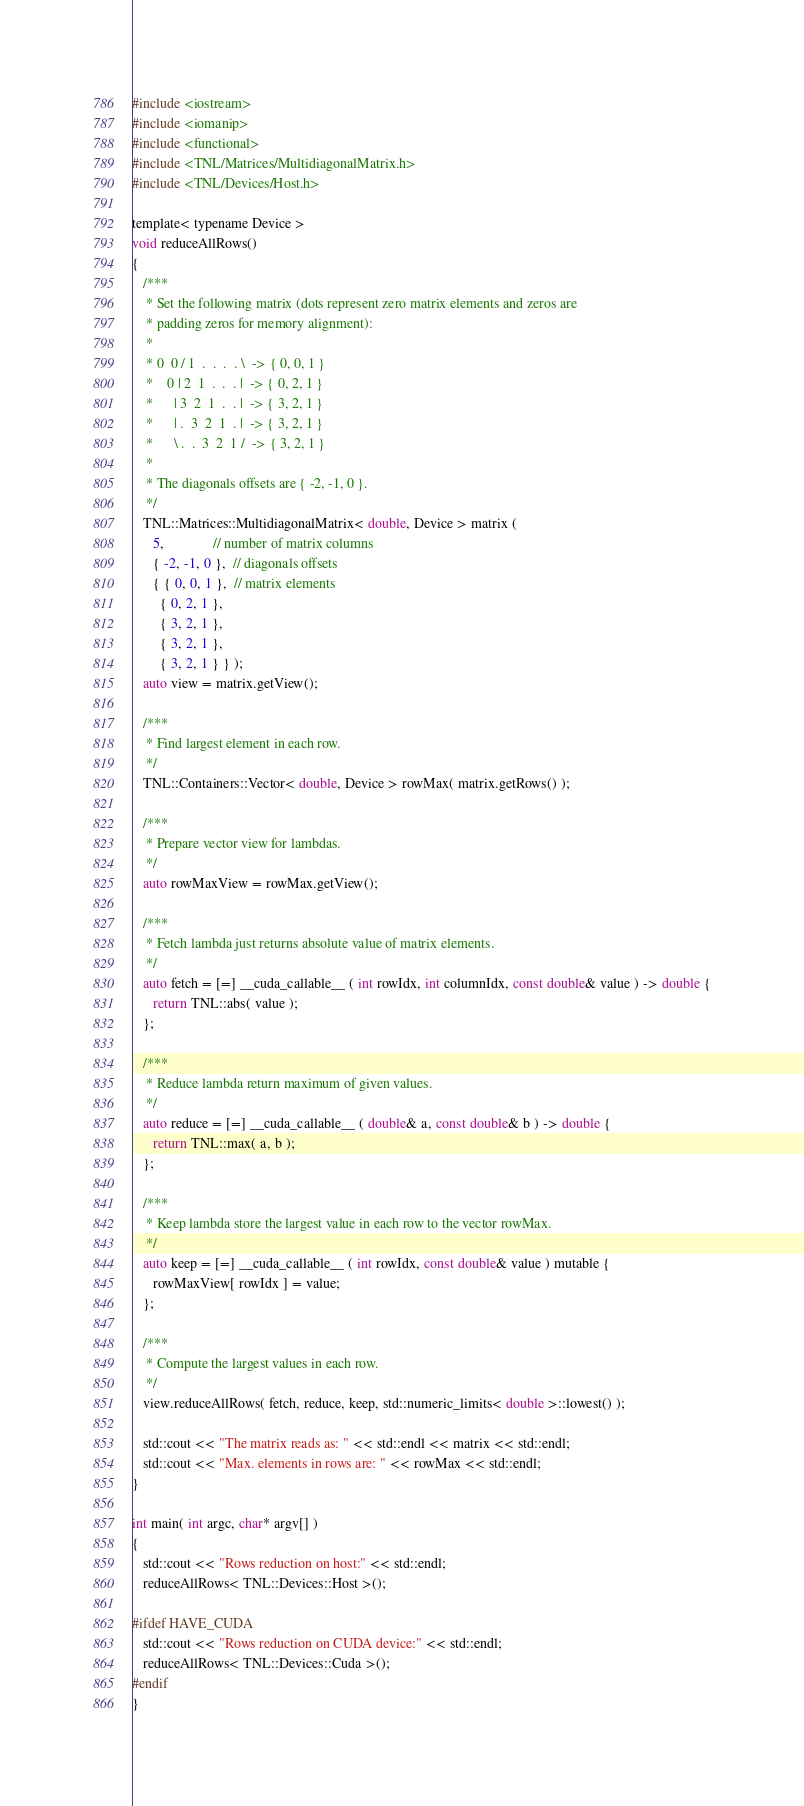Convert code to text. <code><loc_0><loc_0><loc_500><loc_500><_Cuda_>#include <iostream>
#include <iomanip>
#include <functional>
#include <TNL/Matrices/MultidiagonalMatrix.h>
#include <TNL/Devices/Host.h>

template< typename Device >
void reduceAllRows()
{
   /***
    * Set the following matrix (dots represent zero matrix elements and zeros are
    * padding zeros for memory alignment):
    *
    * 0  0 / 1  .  .  .  . \  -> { 0, 0, 1 }
    *    0 | 2  1  .  .  . |  -> { 0, 2, 1 }
    *      | 3  2  1  .  . |  -> { 3, 2, 1 }
    *      | .  3  2  1  . |  -> { 3, 2, 1 }
    *      \ .  .  3  2  1 /  -> { 3, 2, 1 }
    *
    * The diagonals offsets are { -2, -1, 0 }.
    */
   TNL::Matrices::MultidiagonalMatrix< double, Device > matrix (
      5,              // number of matrix columns
      { -2, -1, 0 },  // diagonals offsets
      { { 0, 0, 1 },  // matrix elements
        { 0, 2, 1 },
        { 3, 2, 1 },
        { 3, 2, 1 },
        { 3, 2, 1 } } );
   auto view = matrix.getView();

   /***
    * Find largest element in each row.
    */
   TNL::Containers::Vector< double, Device > rowMax( matrix.getRows() );

   /***
    * Prepare vector view for lambdas.
    */
   auto rowMaxView = rowMax.getView();

   /***
    * Fetch lambda just returns absolute value of matrix elements.
    */
   auto fetch = [=] __cuda_callable__ ( int rowIdx, int columnIdx, const double& value ) -> double {
      return TNL::abs( value );
   };

   /***
    * Reduce lambda return maximum of given values.
    */
   auto reduce = [=] __cuda_callable__ ( double& a, const double& b ) -> double {
      return TNL::max( a, b );
   };

   /***
    * Keep lambda store the largest value in each row to the vector rowMax.
    */
   auto keep = [=] __cuda_callable__ ( int rowIdx, const double& value ) mutable {
      rowMaxView[ rowIdx ] = value;
   };

   /***
    * Compute the largest values in each row.
    */
   view.reduceAllRows( fetch, reduce, keep, std::numeric_limits< double >::lowest() );

   std::cout << "The matrix reads as: " << std::endl << matrix << std::endl;
   std::cout << "Max. elements in rows are: " << rowMax << std::endl;
}

int main( int argc, char* argv[] )
{
   std::cout << "Rows reduction on host:" << std::endl;
   reduceAllRows< TNL::Devices::Host >();

#ifdef HAVE_CUDA
   std::cout << "Rows reduction on CUDA device:" << std::endl;
   reduceAllRows< TNL::Devices::Cuda >();
#endif
}
</code> 